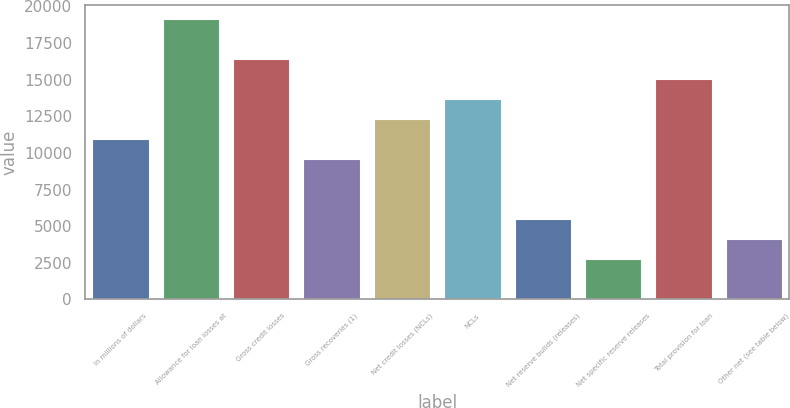<chart> <loc_0><loc_0><loc_500><loc_500><bar_chart><fcel>In millions of dollars<fcel>Allowance for loan losses at<fcel>Gross credit losses<fcel>Gross recoveries (1)<fcel>Net credit losses (NCLs)<fcel>NCLs<fcel>Net reserve builds (releases)<fcel>Net specific reserve releases<fcel>Total provision for loan<fcel>Other net (see table below)<nl><fcel>10946.4<fcel>19153.2<fcel>16417.6<fcel>9578.6<fcel>12314.2<fcel>13682<fcel>5475.2<fcel>2739.6<fcel>15049.8<fcel>4107.4<nl></chart> 